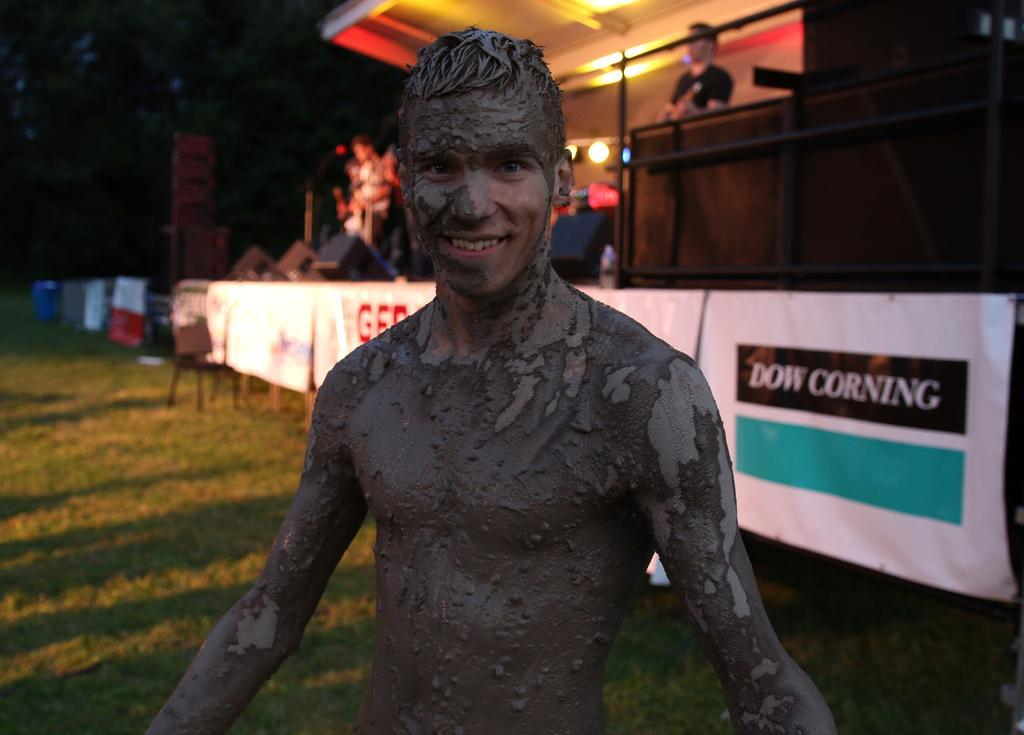Please provide a concise description of this image. In this image we can see a person with mud on the body. On the ground there is grass. In the back there are banners. In the background there is a stage with speakers and lights. Also there are people. In the background there are trees. 